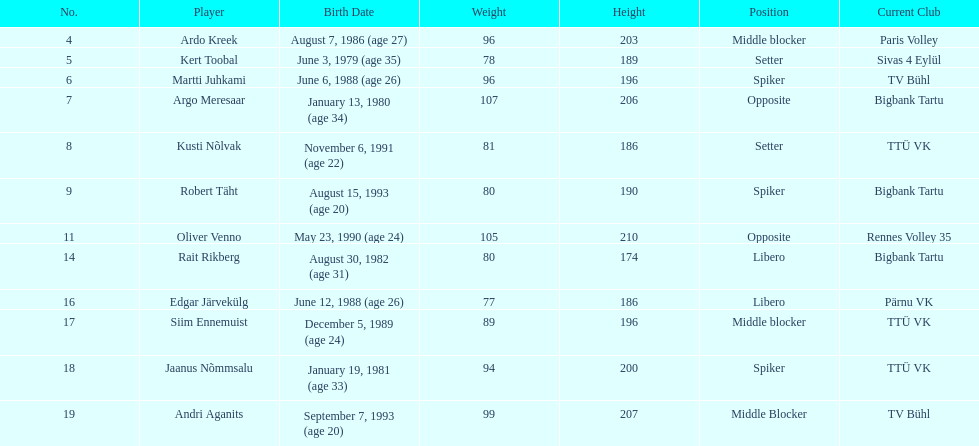Who are all the members? Ardo Kreek, Kert Toobal, Martti Juhkami, Argo Meresaar, Kusti Nõlvak, Robert Täht, Oliver Venno, Rait Rikberg, Edgar Järvekülg, Siim Ennemuist, Jaanus Nõmmsalu, Andri Aganits. What is their height? 203, 189, 196, 206, 186, 190, 210, 174, 186, 196, 200, 207. And which member is the tallest? Oliver Venno. 